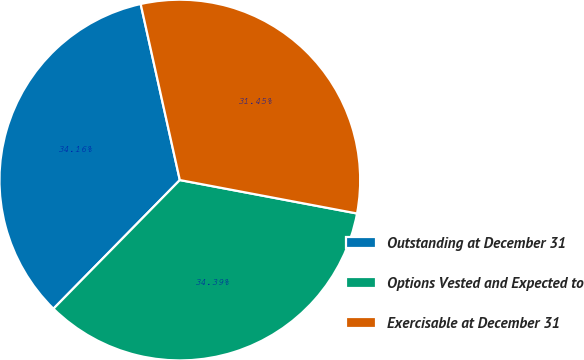Convert chart to OTSL. <chart><loc_0><loc_0><loc_500><loc_500><pie_chart><fcel>Outstanding at December 31<fcel>Options Vested and Expected to<fcel>Exercisable at December 31<nl><fcel>34.16%<fcel>34.39%<fcel>31.45%<nl></chart> 